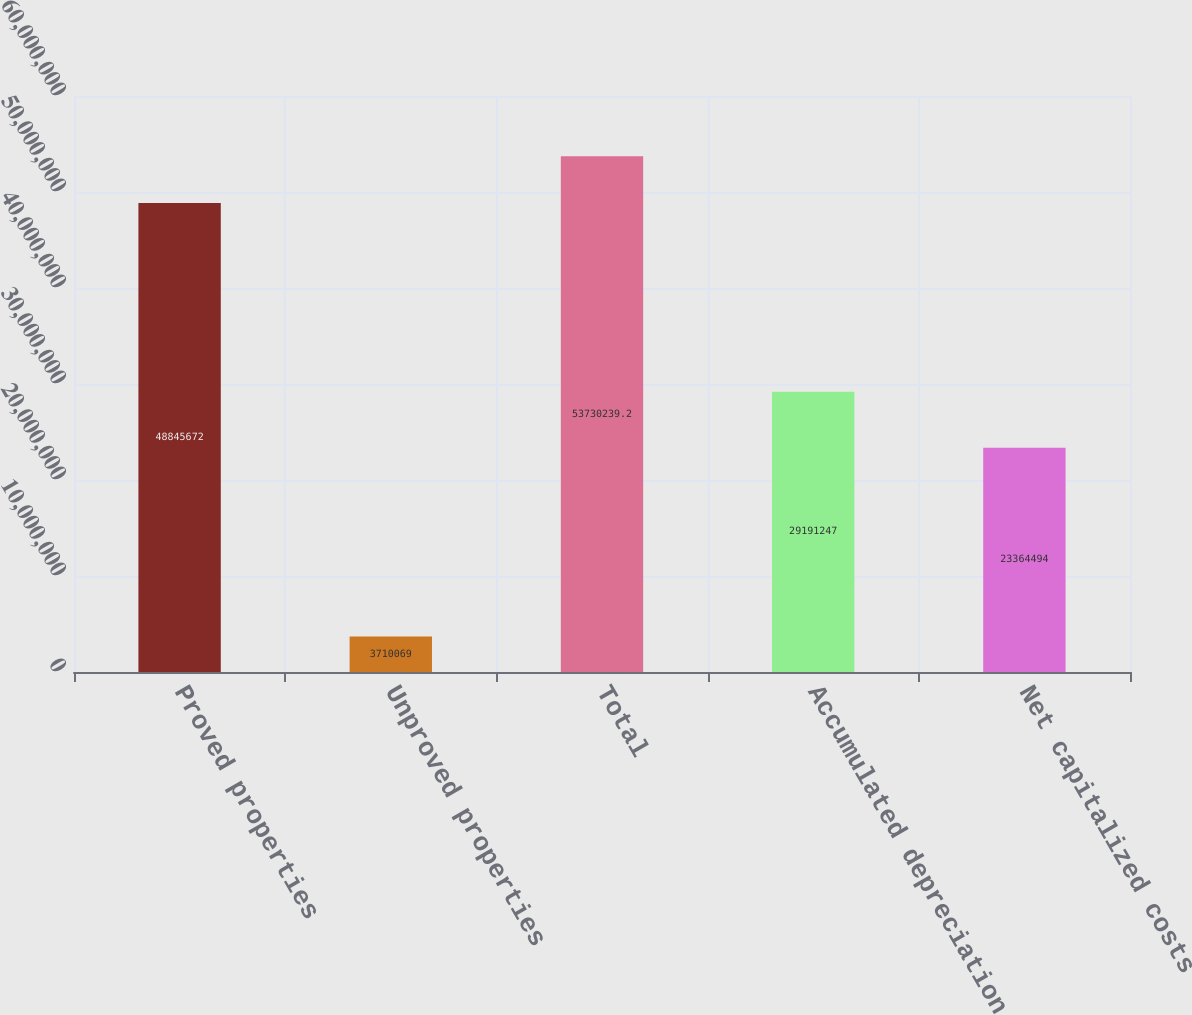Convert chart. <chart><loc_0><loc_0><loc_500><loc_500><bar_chart><fcel>Proved properties<fcel>Unproved properties<fcel>Total<fcel>Accumulated depreciation<fcel>Net capitalized costs<nl><fcel>4.88457e+07<fcel>3.71007e+06<fcel>5.37302e+07<fcel>2.91912e+07<fcel>2.33645e+07<nl></chart> 